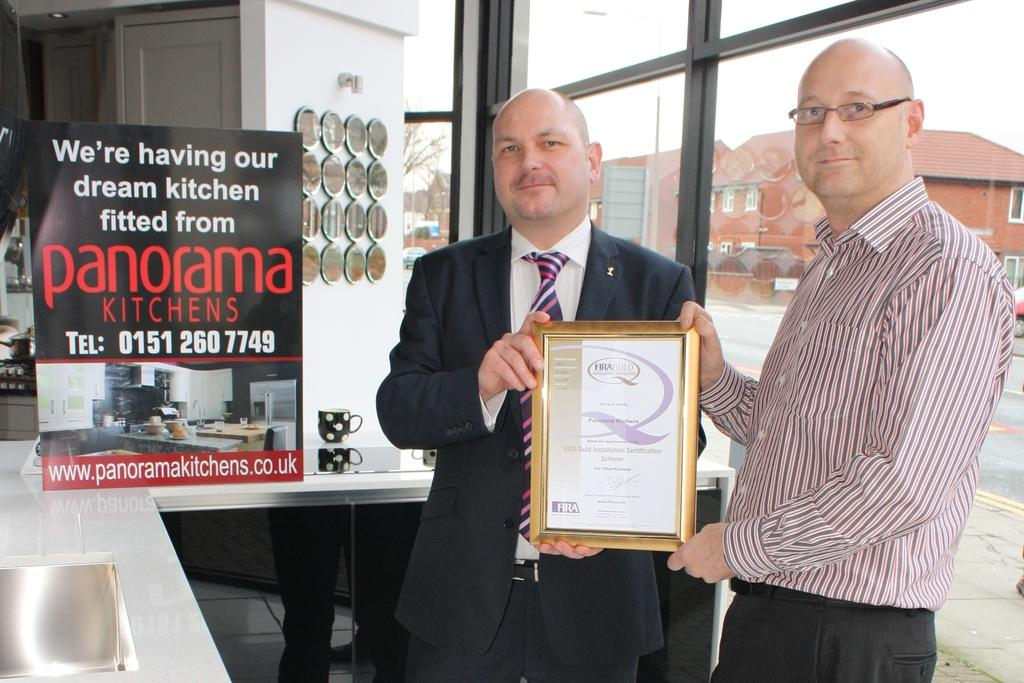<image>
Write a terse but informative summary of the picture. Two men hold up a framed paper near a panorama kitchens sign. 